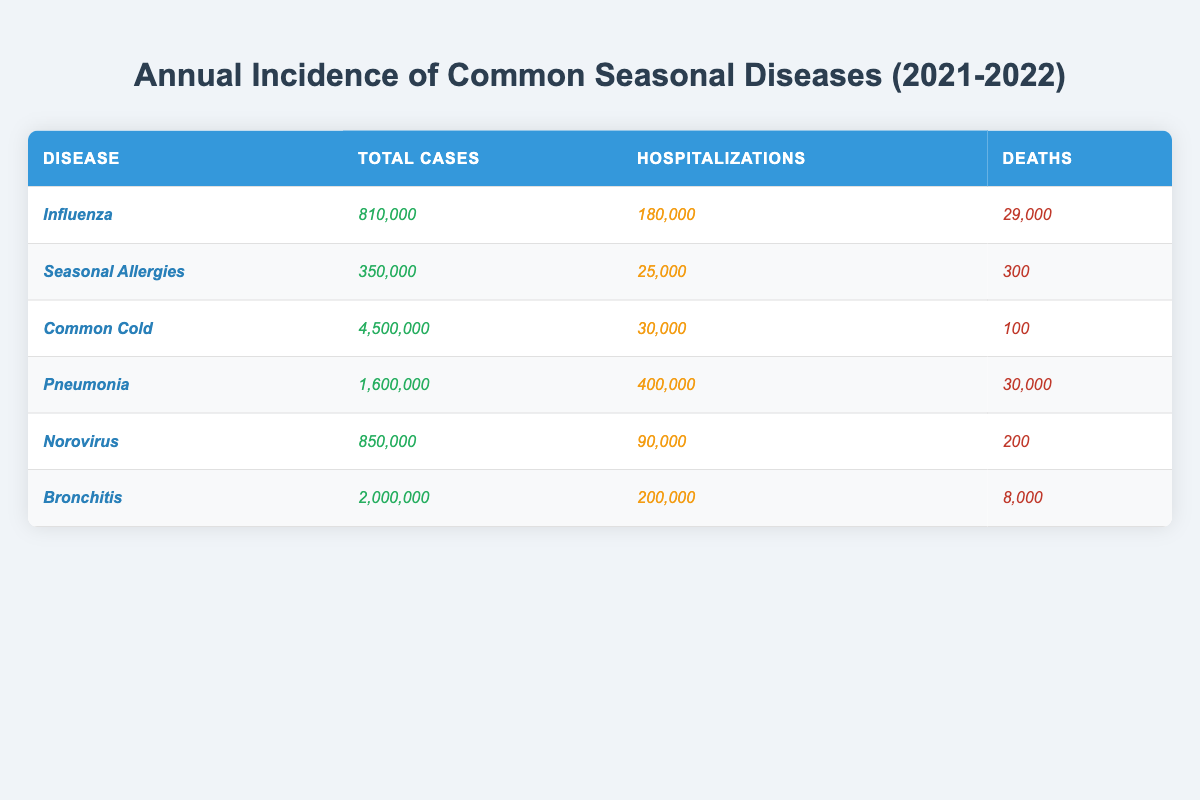What is the total number of cases for pneumonia? The table lists pneumonia under diseases with a total case count of 1,600,000.
Answer: 1,600,000 How many deaths were reported for seasonal allergies? The table specifies that seasonal allergies resulted in 300 deaths in 2021-2022.
Answer: 300 Which disease had the highest number of hospitalizations? Upon comparison, pneumonia had the highest number of hospitalizations at 400,000, as indicated in the table.
Answer: Pneumonia What is the total number of deaths for all the diseases combined? By adding the deaths from each disease: 29,000 (influenza) + 300 (seasonal allergies) + 100 (common cold) + 30,000 (pneumonia) + 200 (norovirus) + 8,000 (bronchitis) = 67,600.
Answer: 67,600 Which disease had the lowest total cases, and how many were there? Seasonal allergies had the lowest total cases with a total of 350,000 cases, as seen in the table.
Answer: Seasonal allergies, 350,000 What is the ratio of total cases for the common cold to norovirus? The total cases for common cold is 4,500,000, and for norovirus it is 850,000. The ratio is 4,500,000 / 850,000 = 5.29, approximately 5.3:1.
Answer: 5.3:1 Is the number of hospitalizations for bronchitis greater than that for norovirus? The table shows 200,000 hospitalizations for bronchitis compared to 90,000 for norovirus, indicating that bronchitis has greater hospitalizations.
Answer: Yes What is the average number of deaths across all listed diseases? The deaths for each disease total: 29,000 (influenza) + 300 (seasonal allergies) + 100 (common cold) + 30,000 (pneumonia) + 200 (norovirus) + 8,000 (bronchitis) = 67,600. With 6 diseases, the average is 67,600 / 6 = 11,266.67, approximately 11,267.
Answer: 11,267 How many more total cases does pneumonia have compared to seasonal allergies? Pneumonia has 1,600,000 cases, and seasonal allergies have 350,000. The difference is 1,600,000 - 350,000 = 1,250,000.
Answer: 1,250,000 If you combine the total cases for influenza and norovirus, what is the result? Adding up the total cases for influenza (810,000) and norovirus (850,000) gives 810,000 + 850,000 = 1,660,000.
Answer: 1,660,000 